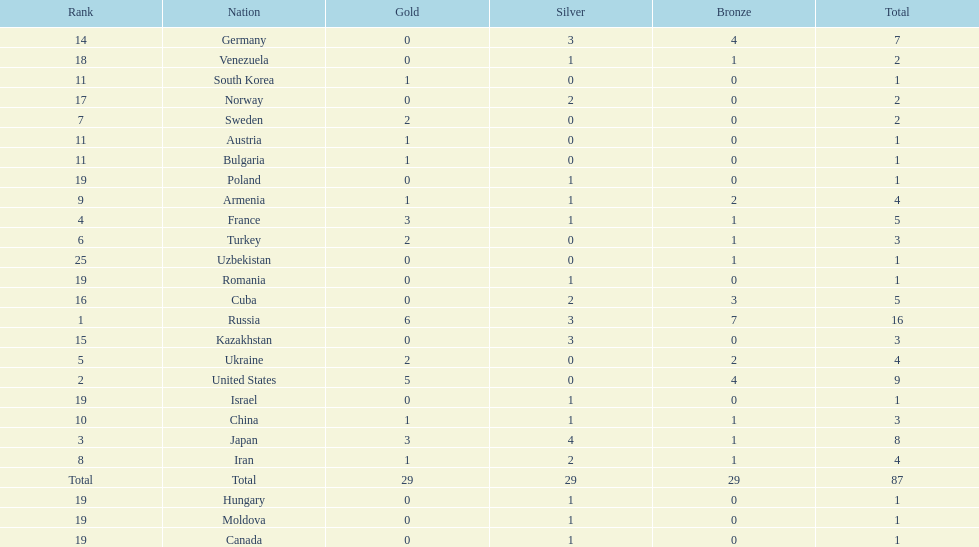How many silver medals did turkey win? 0. 